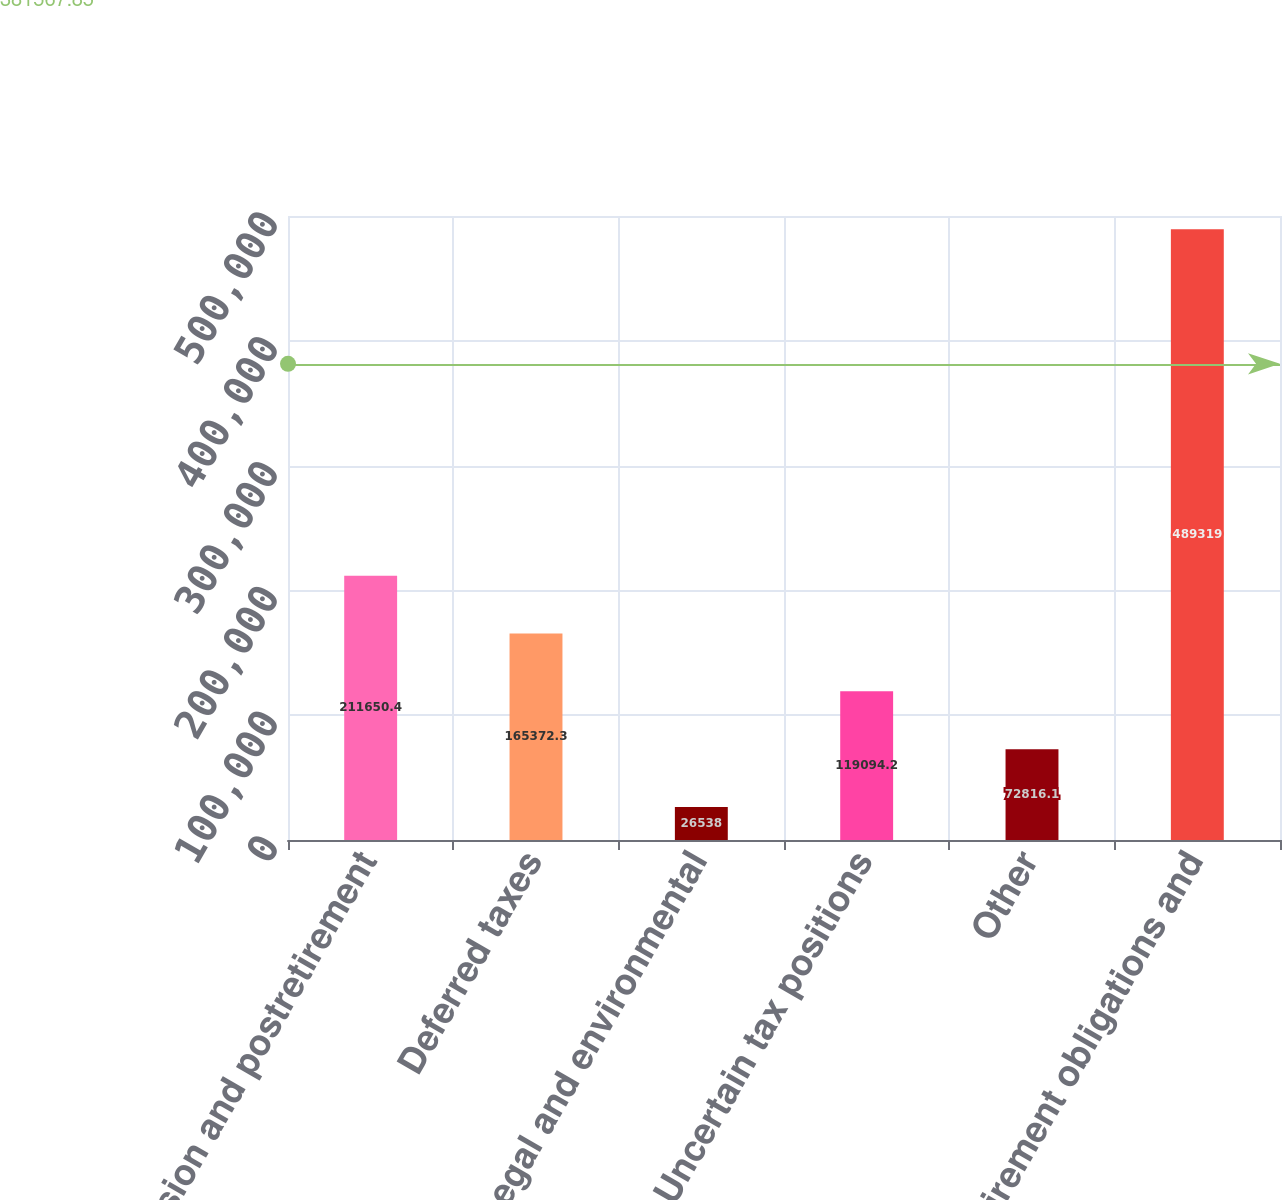<chart> <loc_0><loc_0><loc_500><loc_500><bar_chart><fcel>Pension and postretirement<fcel>Deferred taxes<fcel>Legal and environmental<fcel>Uncertain tax positions<fcel>Other<fcel>Retirement obligations and<nl><fcel>211650<fcel>165372<fcel>26538<fcel>119094<fcel>72816.1<fcel>489319<nl></chart> 